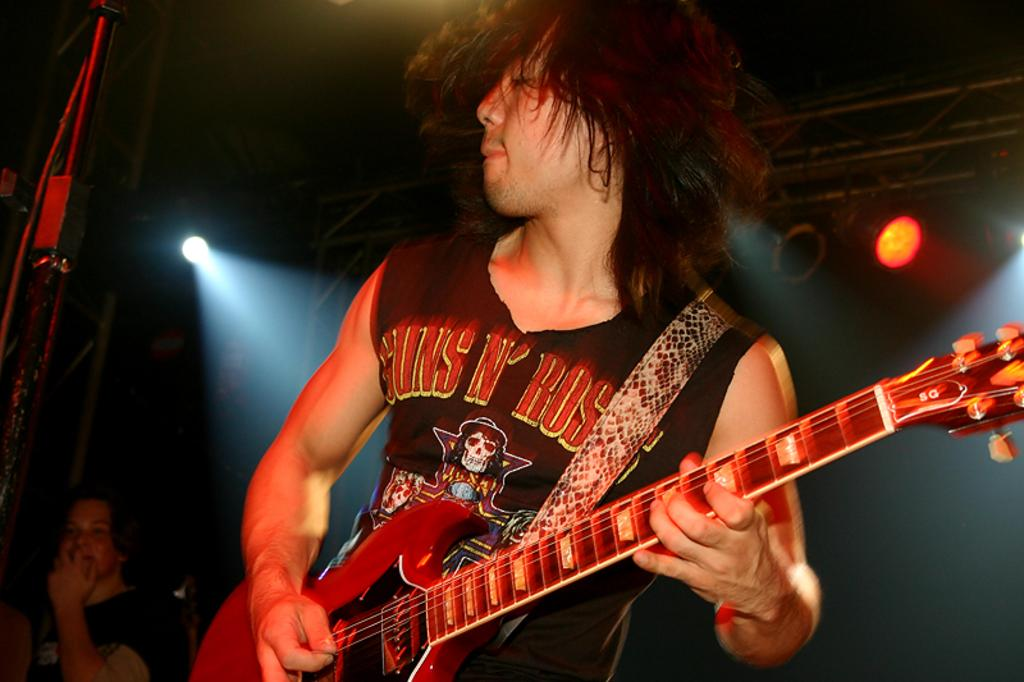What is the main subject of the image? There is a man in the image. What is the man doing in the image? The man is standing in the image. What object is the man holding in the image? The man is holding a guitar in his hands. What can be seen in the background or surroundings of the image? There is a light visible in the image. Where is the cemetery located in the image? There is no cemetery present in the image. What type of drawer can be seen in the image? There is no drawer present in the image. 